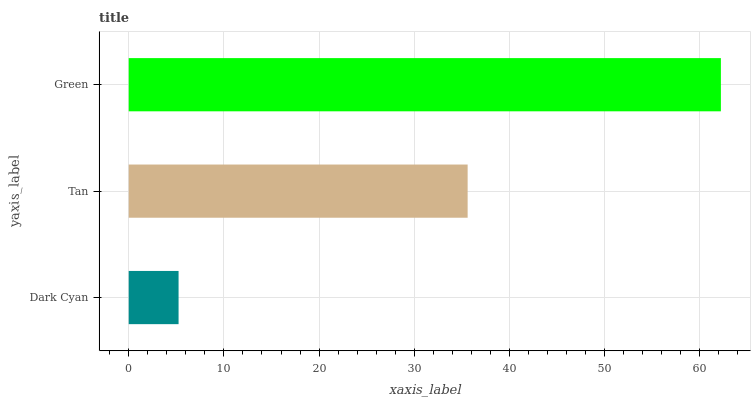Is Dark Cyan the minimum?
Answer yes or no. Yes. Is Green the maximum?
Answer yes or no. Yes. Is Tan the minimum?
Answer yes or no. No. Is Tan the maximum?
Answer yes or no. No. Is Tan greater than Dark Cyan?
Answer yes or no. Yes. Is Dark Cyan less than Tan?
Answer yes or no. Yes. Is Dark Cyan greater than Tan?
Answer yes or no. No. Is Tan less than Dark Cyan?
Answer yes or no. No. Is Tan the high median?
Answer yes or no. Yes. Is Tan the low median?
Answer yes or no. Yes. Is Dark Cyan the high median?
Answer yes or no. No. Is Green the low median?
Answer yes or no. No. 